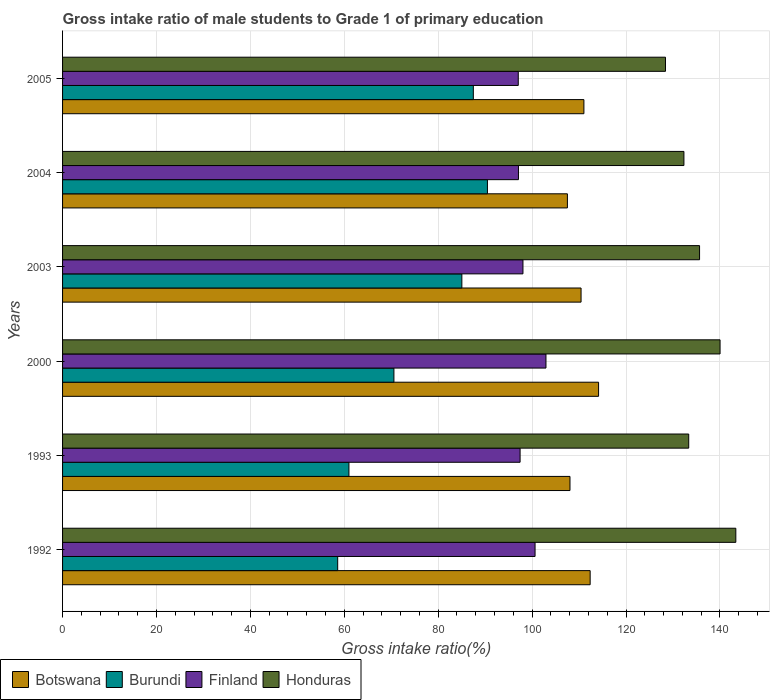Are the number of bars per tick equal to the number of legend labels?
Your answer should be compact. Yes. How many bars are there on the 4th tick from the top?
Provide a succinct answer. 4. What is the label of the 3rd group of bars from the top?
Your answer should be compact. 2003. In how many cases, is the number of bars for a given year not equal to the number of legend labels?
Make the answer very short. 0. What is the gross intake ratio in Botswana in 2005?
Provide a short and direct response. 111.03. Across all years, what is the maximum gross intake ratio in Honduras?
Your answer should be compact. 143.39. Across all years, what is the minimum gross intake ratio in Finland?
Ensure brevity in your answer.  97.05. What is the total gross intake ratio in Finland in the graph?
Your response must be concise. 593.22. What is the difference between the gross intake ratio in Finland in 1992 and that in 1993?
Offer a very short reply. 3.19. What is the difference between the gross intake ratio in Finland in 1992 and the gross intake ratio in Honduras in 2003?
Ensure brevity in your answer.  -35.03. What is the average gross intake ratio in Finland per year?
Provide a succinct answer. 98.87. In the year 2003, what is the difference between the gross intake ratio in Botswana and gross intake ratio in Finland?
Offer a very short reply. 12.38. What is the ratio of the gross intake ratio in Honduras in 2000 to that in 2005?
Keep it short and to the point. 1.09. Is the gross intake ratio in Burundi in 1992 less than that in 1993?
Provide a succinct answer. Yes. Is the difference between the gross intake ratio in Botswana in 1992 and 2003 greater than the difference between the gross intake ratio in Finland in 1992 and 2003?
Your response must be concise. No. What is the difference between the highest and the second highest gross intake ratio in Finland?
Your response must be concise. 2.32. What is the difference between the highest and the lowest gross intake ratio in Botswana?
Offer a terse response. 6.64. In how many years, is the gross intake ratio in Honduras greater than the average gross intake ratio in Honduras taken over all years?
Give a very brief answer. 3. What does the 3rd bar from the top in 2003 represents?
Your answer should be very brief. Burundi. What does the 4th bar from the bottom in 1992 represents?
Offer a terse response. Honduras. Are all the bars in the graph horizontal?
Give a very brief answer. Yes. Does the graph contain any zero values?
Your response must be concise. No. What is the title of the graph?
Keep it short and to the point. Gross intake ratio of male students to Grade 1 of primary education. Does "Seychelles" appear as one of the legend labels in the graph?
Your response must be concise. No. What is the label or title of the X-axis?
Offer a terse response. Gross intake ratio(%). What is the label or title of the Y-axis?
Offer a terse response. Years. What is the Gross intake ratio(%) in Botswana in 1992?
Your answer should be very brief. 112.36. What is the Gross intake ratio(%) in Burundi in 1992?
Make the answer very short. 58.59. What is the Gross intake ratio(%) of Finland in 1992?
Offer a terse response. 100.63. What is the Gross intake ratio(%) of Honduras in 1992?
Your response must be concise. 143.39. What is the Gross intake ratio(%) in Botswana in 1993?
Keep it short and to the point. 108.07. What is the Gross intake ratio(%) in Burundi in 1993?
Your response must be concise. 60.99. What is the Gross intake ratio(%) of Finland in 1993?
Keep it short and to the point. 97.44. What is the Gross intake ratio(%) of Honduras in 1993?
Make the answer very short. 133.35. What is the Gross intake ratio(%) of Botswana in 2000?
Your answer should be very brief. 114.16. What is the Gross intake ratio(%) of Burundi in 2000?
Ensure brevity in your answer.  70.57. What is the Gross intake ratio(%) in Finland in 2000?
Your response must be concise. 102.95. What is the Gross intake ratio(%) of Honduras in 2000?
Make the answer very short. 140.03. What is the Gross intake ratio(%) in Botswana in 2003?
Ensure brevity in your answer.  110.42. What is the Gross intake ratio(%) of Burundi in 2003?
Your response must be concise. 85.04. What is the Gross intake ratio(%) in Finland in 2003?
Keep it short and to the point. 98.05. What is the Gross intake ratio(%) in Honduras in 2003?
Offer a very short reply. 135.66. What is the Gross intake ratio(%) in Botswana in 2004?
Offer a very short reply. 107.52. What is the Gross intake ratio(%) of Burundi in 2004?
Provide a short and direct response. 90.48. What is the Gross intake ratio(%) of Finland in 2004?
Provide a short and direct response. 97.09. What is the Gross intake ratio(%) in Honduras in 2004?
Your response must be concise. 132.33. What is the Gross intake ratio(%) of Botswana in 2005?
Provide a succinct answer. 111.03. What is the Gross intake ratio(%) of Burundi in 2005?
Your answer should be compact. 87.48. What is the Gross intake ratio(%) in Finland in 2005?
Your answer should be very brief. 97.05. What is the Gross intake ratio(%) of Honduras in 2005?
Provide a succinct answer. 128.41. Across all years, what is the maximum Gross intake ratio(%) of Botswana?
Ensure brevity in your answer.  114.16. Across all years, what is the maximum Gross intake ratio(%) in Burundi?
Give a very brief answer. 90.48. Across all years, what is the maximum Gross intake ratio(%) in Finland?
Provide a short and direct response. 102.95. Across all years, what is the maximum Gross intake ratio(%) in Honduras?
Offer a very short reply. 143.39. Across all years, what is the minimum Gross intake ratio(%) in Botswana?
Offer a terse response. 107.52. Across all years, what is the minimum Gross intake ratio(%) in Burundi?
Provide a short and direct response. 58.59. Across all years, what is the minimum Gross intake ratio(%) of Finland?
Keep it short and to the point. 97.05. Across all years, what is the minimum Gross intake ratio(%) of Honduras?
Make the answer very short. 128.41. What is the total Gross intake ratio(%) in Botswana in the graph?
Your response must be concise. 663.56. What is the total Gross intake ratio(%) in Burundi in the graph?
Give a very brief answer. 453.16. What is the total Gross intake ratio(%) in Finland in the graph?
Your answer should be compact. 593.22. What is the total Gross intake ratio(%) of Honduras in the graph?
Offer a terse response. 813.17. What is the difference between the Gross intake ratio(%) of Botswana in 1992 and that in 1993?
Keep it short and to the point. 4.29. What is the difference between the Gross intake ratio(%) in Burundi in 1992 and that in 1993?
Provide a succinct answer. -2.4. What is the difference between the Gross intake ratio(%) in Finland in 1992 and that in 1993?
Give a very brief answer. 3.19. What is the difference between the Gross intake ratio(%) in Honduras in 1992 and that in 1993?
Offer a very short reply. 10.03. What is the difference between the Gross intake ratio(%) in Botswana in 1992 and that in 2000?
Make the answer very short. -1.79. What is the difference between the Gross intake ratio(%) of Burundi in 1992 and that in 2000?
Make the answer very short. -11.97. What is the difference between the Gross intake ratio(%) in Finland in 1992 and that in 2000?
Ensure brevity in your answer.  -2.32. What is the difference between the Gross intake ratio(%) of Honduras in 1992 and that in 2000?
Ensure brevity in your answer.  3.36. What is the difference between the Gross intake ratio(%) of Botswana in 1992 and that in 2003?
Make the answer very short. 1.94. What is the difference between the Gross intake ratio(%) in Burundi in 1992 and that in 2003?
Provide a succinct answer. -26.44. What is the difference between the Gross intake ratio(%) in Finland in 1992 and that in 2003?
Provide a succinct answer. 2.58. What is the difference between the Gross intake ratio(%) of Honduras in 1992 and that in 2003?
Provide a succinct answer. 7.72. What is the difference between the Gross intake ratio(%) in Botswana in 1992 and that in 2004?
Offer a very short reply. 4.84. What is the difference between the Gross intake ratio(%) in Burundi in 1992 and that in 2004?
Provide a succinct answer. -31.89. What is the difference between the Gross intake ratio(%) in Finland in 1992 and that in 2004?
Your answer should be compact. 3.54. What is the difference between the Gross intake ratio(%) of Honduras in 1992 and that in 2004?
Your answer should be very brief. 11.05. What is the difference between the Gross intake ratio(%) in Botswana in 1992 and that in 2005?
Give a very brief answer. 1.33. What is the difference between the Gross intake ratio(%) in Burundi in 1992 and that in 2005?
Provide a short and direct response. -28.89. What is the difference between the Gross intake ratio(%) of Finland in 1992 and that in 2005?
Offer a very short reply. 3.58. What is the difference between the Gross intake ratio(%) of Honduras in 1992 and that in 2005?
Offer a terse response. 14.98. What is the difference between the Gross intake ratio(%) in Botswana in 1993 and that in 2000?
Your answer should be compact. -6.09. What is the difference between the Gross intake ratio(%) of Burundi in 1993 and that in 2000?
Ensure brevity in your answer.  -9.58. What is the difference between the Gross intake ratio(%) in Finland in 1993 and that in 2000?
Provide a succinct answer. -5.51. What is the difference between the Gross intake ratio(%) in Honduras in 1993 and that in 2000?
Your answer should be very brief. -6.68. What is the difference between the Gross intake ratio(%) of Botswana in 1993 and that in 2003?
Keep it short and to the point. -2.36. What is the difference between the Gross intake ratio(%) of Burundi in 1993 and that in 2003?
Give a very brief answer. -24.05. What is the difference between the Gross intake ratio(%) in Finland in 1993 and that in 2003?
Offer a terse response. -0.61. What is the difference between the Gross intake ratio(%) in Honduras in 1993 and that in 2003?
Make the answer very short. -2.31. What is the difference between the Gross intake ratio(%) of Botswana in 1993 and that in 2004?
Offer a terse response. 0.55. What is the difference between the Gross intake ratio(%) of Burundi in 1993 and that in 2004?
Provide a succinct answer. -29.49. What is the difference between the Gross intake ratio(%) in Finland in 1993 and that in 2004?
Your answer should be compact. 0.35. What is the difference between the Gross intake ratio(%) in Honduras in 1993 and that in 2004?
Provide a short and direct response. 1.02. What is the difference between the Gross intake ratio(%) of Botswana in 1993 and that in 2005?
Provide a succinct answer. -2.97. What is the difference between the Gross intake ratio(%) in Burundi in 1993 and that in 2005?
Keep it short and to the point. -26.49. What is the difference between the Gross intake ratio(%) of Finland in 1993 and that in 2005?
Make the answer very short. 0.39. What is the difference between the Gross intake ratio(%) of Honduras in 1993 and that in 2005?
Your answer should be very brief. 4.95. What is the difference between the Gross intake ratio(%) in Botswana in 2000 and that in 2003?
Ensure brevity in your answer.  3.73. What is the difference between the Gross intake ratio(%) in Burundi in 2000 and that in 2003?
Make the answer very short. -14.47. What is the difference between the Gross intake ratio(%) of Finland in 2000 and that in 2003?
Provide a short and direct response. 4.9. What is the difference between the Gross intake ratio(%) of Honduras in 2000 and that in 2003?
Offer a terse response. 4.37. What is the difference between the Gross intake ratio(%) of Botswana in 2000 and that in 2004?
Ensure brevity in your answer.  6.64. What is the difference between the Gross intake ratio(%) of Burundi in 2000 and that in 2004?
Keep it short and to the point. -19.92. What is the difference between the Gross intake ratio(%) in Finland in 2000 and that in 2004?
Provide a succinct answer. 5.86. What is the difference between the Gross intake ratio(%) in Honduras in 2000 and that in 2004?
Give a very brief answer. 7.7. What is the difference between the Gross intake ratio(%) of Botswana in 2000 and that in 2005?
Your response must be concise. 3.12. What is the difference between the Gross intake ratio(%) in Burundi in 2000 and that in 2005?
Your answer should be very brief. -16.91. What is the difference between the Gross intake ratio(%) in Finland in 2000 and that in 2005?
Your response must be concise. 5.9. What is the difference between the Gross intake ratio(%) of Honduras in 2000 and that in 2005?
Your response must be concise. 11.62. What is the difference between the Gross intake ratio(%) in Botswana in 2003 and that in 2004?
Your answer should be compact. 2.91. What is the difference between the Gross intake ratio(%) in Burundi in 2003 and that in 2004?
Make the answer very short. -5.45. What is the difference between the Gross intake ratio(%) in Finland in 2003 and that in 2004?
Make the answer very short. 0.96. What is the difference between the Gross intake ratio(%) in Honduras in 2003 and that in 2004?
Your answer should be compact. 3.33. What is the difference between the Gross intake ratio(%) in Botswana in 2003 and that in 2005?
Offer a very short reply. -0.61. What is the difference between the Gross intake ratio(%) in Burundi in 2003 and that in 2005?
Give a very brief answer. -2.44. What is the difference between the Gross intake ratio(%) in Finland in 2003 and that in 2005?
Ensure brevity in your answer.  1. What is the difference between the Gross intake ratio(%) of Honduras in 2003 and that in 2005?
Offer a very short reply. 7.26. What is the difference between the Gross intake ratio(%) in Botswana in 2004 and that in 2005?
Ensure brevity in your answer.  -3.52. What is the difference between the Gross intake ratio(%) in Burundi in 2004 and that in 2005?
Your response must be concise. 3. What is the difference between the Gross intake ratio(%) in Finland in 2004 and that in 2005?
Make the answer very short. 0.04. What is the difference between the Gross intake ratio(%) of Honduras in 2004 and that in 2005?
Offer a very short reply. 3.93. What is the difference between the Gross intake ratio(%) in Botswana in 1992 and the Gross intake ratio(%) in Burundi in 1993?
Offer a terse response. 51.37. What is the difference between the Gross intake ratio(%) in Botswana in 1992 and the Gross intake ratio(%) in Finland in 1993?
Offer a terse response. 14.92. What is the difference between the Gross intake ratio(%) of Botswana in 1992 and the Gross intake ratio(%) of Honduras in 1993?
Provide a succinct answer. -20.99. What is the difference between the Gross intake ratio(%) in Burundi in 1992 and the Gross intake ratio(%) in Finland in 1993?
Keep it short and to the point. -38.85. What is the difference between the Gross intake ratio(%) in Burundi in 1992 and the Gross intake ratio(%) in Honduras in 1993?
Give a very brief answer. -74.76. What is the difference between the Gross intake ratio(%) in Finland in 1992 and the Gross intake ratio(%) in Honduras in 1993?
Offer a very short reply. -32.73. What is the difference between the Gross intake ratio(%) of Botswana in 1992 and the Gross intake ratio(%) of Burundi in 2000?
Provide a succinct answer. 41.79. What is the difference between the Gross intake ratio(%) of Botswana in 1992 and the Gross intake ratio(%) of Finland in 2000?
Make the answer very short. 9.41. What is the difference between the Gross intake ratio(%) in Botswana in 1992 and the Gross intake ratio(%) in Honduras in 2000?
Make the answer very short. -27.67. What is the difference between the Gross intake ratio(%) in Burundi in 1992 and the Gross intake ratio(%) in Finland in 2000?
Ensure brevity in your answer.  -44.36. What is the difference between the Gross intake ratio(%) in Burundi in 1992 and the Gross intake ratio(%) in Honduras in 2000?
Ensure brevity in your answer.  -81.44. What is the difference between the Gross intake ratio(%) in Finland in 1992 and the Gross intake ratio(%) in Honduras in 2000?
Provide a short and direct response. -39.4. What is the difference between the Gross intake ratio(%) of Botswana in 1992 and the Gross intake ratio(%) of Burundi in 2003?
Keep it short and to the point. 27.32. What is the difference between the Gross intake ratio(%) in Botswana in 1992 and the Gross intake ratio(%) in Finland in 2003?
Make the answer very short. 14.31. What is the difference between the Gross intake ratio(%) of Botswana in 1992 and the Gross intake ratio(%) of Honduras in 2003?
Offer a terse response. -23.3. What is the difference between the Gross intake ratio(%) in Burundi in 1992 and the Gross intake ratio(%) in Finland in 2003?
Offer a terse response. -39.45. What is the difference between the Gross intake ratio(%) in Burundi in 1992 and the Gross intake ratio(%) in Honduras in 2003?
Make the answer very short. -77.07. What is the difference between the Gross intake ratio(%) of Finland in 1992 and the Gross intake ratio(%) of Honduras in 2003?
Keep it short and to the point. -35.03. What is the difference between the Gross intake ratio(%) in Botswana in 1992 and the Gross intake ratio(%) in Burundi in 2004?
Your answer should be compact. 21.88. What is the difference between the Gross intake ratio(%) in Botswana in 1992 and the Gross intake ratio(%) in Finland in 2004?
Your answer should be compact. 15.27. What is the difference between the Gross intake ratio(%) of Botswana in 1992 and the Gross intake ratio(%) of Honduras in 2004?
Your response must be concise. -19.97. What is the difference between the Gross intake ratio(%) in Burundi in 1992 and the Gross intake ratio(%) in Finland in 2004?
Give a very brief answer. -38.5. What is the difference between the Gross intake ratio(%) of Burundi in 1992 and the Gross intake ratio(%) of Honduras in 2004?
Offer a very short reply. -73.74. What is the difference between the Gross intake ratio(%) of Finland in 1992 and the Gross intake ratio(%) of Honduras in 2004?
Keep it short and to the point. -31.7. What is the difference between the Gross intake ratio(%) of Botswana in 1992 and the Gross intake ratio(%) of Burundi in 2005?
Your answer should be very brief. 24.88. What is the difference between the Gross intake ratio(%) in Botswana in 1992 and the Gross intake ratio(%) in Finland in 2005?
Provide a succinct answer. 15.31. What is the difference between the Gross intake ratio(%) in Botswana in 1992 and the Gross intake ratio(%) in Honduras in 2005?
Provide a succinct answer. -16.04. What is the difference between the Gross intake ratio(%) in Burundi in 1992 and the Gross intake ratio(%) in Finland in 2005?
Provide a short and direct response. -38.46. What is the difference between the Gross intake ratio(%) of Burundi in 1992 and the Gross intake ratio(%) of Honduras in 2005?
Provide a short and direct response. -69.81. What is the difference between the Gross intake ratio(%) in Finland in 1992 and the Gross intake ratio(%) in Honduras in 2005?
Ensure brevity in your answer.  -27.78. What is the difference between the Gross intake ratio(%) of Botswana in 1993 and the Gross intake ratio(%) of Burundi in 2000?
Your response must be concise. 37.5. What is the difference between the Gross intake ratio(%) of Botswana in 1993 and the Gross intake ratio(%) of Finland in 2000?
Make the answer very short. 5.11. What is the difference between the Gross intake ratio(%) in Botswana in 1993 and the Gross intake ratio(%) in Honduras in 2000?
Your answer should be very brief. -31.96. What is the difference between the Gross intake ratio(%) of Burundi in 1993 and the Gross intake ratio(%) of Finland in 2000?
Offer a terse response. -41.96. What is the difference between the Gross intake ratio(%) of Burundi in 1993 and the Gross intake ratio(%) of Honduras in 2000?
Offer a very short reply. -79.04. What is the difference between the Gross intake ratio(%) of Finland in 1993 and the Gross intake ratio(%) of Honduras in 2000?
Keep it short and to the point. -42.59. What is the difference between the Gross intake ratio(%) of Botswana in 1993 and the Gross intake ratio(%) of Burundi in 2003?
Your response must be concise. 23.03. What is the difference between the Gross intake ratio(%) of Botswana in 1993 and the Gross intake ratio(%) of Finland in 2003?
Offer a terse response. 10.02. What is the difference between the Gross intake ratio(%) in Botswana in 1993 and the Gross intake ratio(%) in Honduras in 2003?
Your answer should be very brief. -27.6. What is the difference between the Gross intake ratio(%) of Burundi in 1993 and the Gross intake ratio(%) of Finland in 2003?
Give a very brief answer. -37.06. What is the difference between the Gross intake ratio(%) of Burundi in 1993 and the Gross intake ratio(%) of Honduras in 2003?
Give a very brief answer. -74.67. What is the difference between the Gross intake ratio(%) in Finland in 1993 and the Gross intake ratio(%) in Honduras in 2003?
Offer a terse response. -38.22. What is the difference between the Gross intake ratio(%) of Botswana in 1993 and the Gross intake ratio(%) of Burundi in 2004?
Provide a succinct answer. 17.58. What is the difference between the Gross intake ratio(%) of Botswana in 1993 and the Gross intake ratio(%) of Finland in 2004?
Ensure brevity in your answer.  10.97. What is the difference between the Gross intake ratio(%) of Botswana in 1993 and the Gross intake ratio(%) of Honduras in 2004?
Offer a very short reply. -24.27. What is the difference between the Gross intake ratio(%) in Burundi in 1993 and the Gross intake ratio(%) in Finland in 2004?
Provide a succinct answer. -36.1. What is the difference between the Gross intake ratio(%) of Burundi in 1993 and the Gross intake ratio(%) of Honduras in 2004?
Your answer should be very brief. -71.34. What is the difference between the Gross intake ratio(%) of Finland in 1993 and the Gross intake ratio(%) of Honduras in 2004?
Provide a short and direct response. -34.89. What is the difference between the Gross intake ratio(%) in Botswana in 1993 and the Gross intake ratio(%) in Burundi in 2005?
Keep it short and to the point. 20.59. What is the difference between the Gross intake ratio(%) of Botswana in 1993 and the Gross intake ratio(%) of Finland in 2005?
Give a very brief answer. 11.01. What is the difference between the Gross intake ratio(%) in Botswana in 1993 and the Gross intake ratio(%) in Honduras in 2005?
Offer a very short reply. -20.34. What is the difference between the Gross intake ratio(%) of Burundi in 1993 and the Gross intake ratio(%) of Finland in 2005?
Give a very brief answer. -36.06. What is the difference between the Gross intake ratio(%) in Burundi in 1993 and the Gross intake ratio(%) in Honduras in 2005?
Your answer should be compact. -67.42. What is the difference between the Gross intake ratio(%) in Finland in 1993 and the Gross intake ratio(%) in Honduras in 2005?
Provide a short and direct response. -30.97. What is the difference between the Gross intake ratio(%) in Botswana in 2000 and the Gross intake ratio(%) in Burundi in 2003?
Your answer should be very brief. 29.12. What is the difference between the Gross intake ratio(%) of Botswana in 2000 and the Gross intake ratio(%) of Finland in 2003?
Make the answer very short. 16.11. What is the difference between the Gross intake ratio(%) of Botswana in 2000 and the Gross intake ratio(%) of Honduras in 2003?
Provide a succinct answer. -21.51. What is the difference between the Gross intake ratio(%) of Burundi in 2000 and the Gross intake ratio(%) of Finland in 2003?
Give a very brief answer. -27.48. What is the difference between the Gross intake ratio(%) in Burundi in 2000 and the Gross intake ratio(%) in Honduras in 2003?
Your answer should be compact. -65.09. What is the difference between the Gross intake ratio(%) in Finland in 2000 and the Gross intake ratio(%) in Honduras in 2003?
Provide a succinct answer. -32.71. What is the difference between the Gross intake ratio(%) in Botswana in 2000 and the Gross intake ratio(%) in Burundi in 2004?
Make the answer very short. 23.67. What is the difference between the Gross intake ratio(%) in Botswana in 2000 and the Gross intake ratio(%) in Finland in 2004?
Keep it short and to the point. 17.06. What is the difference between the Gross intake ratio(%) of Botswana in 2000 and the Gross intake ratio(%) of Honduras in 2004?
Make the answer very short. -18.18. What is the difference between the Gross intake ratio(%) in Burundi in 2000 and the Gross intake ratio(%) in Finland in 2004?
Make the answer very short. -26.52. What is the difference between the Gross intake ratio(%) in Burundi in 2000 and the Gross intake ratio(%) in Honduras in 2004?
Ensure brevity in your answer.  -61.77. What is the difference between the Gross intake ratio(%) of Finland in 2000 and the Gross intake ratio(%) of Honduras in 2004?
Give a very brief answer. -29.38. What is the difference between the Gross intake ratio(%) in Botswana in 2000 and the Gross intake ratio(%) in Burundi in 2005?
Provide a short and direct response. 26.67. What is the difference between the Gross intake ratio(%) of Botswana in 2000 and the Gross intake ratio(%) of Finland in 2005?
Keep it short and to the point. 17.1. What is the difference between the Gross intake ratio(%) of Botswana in 2000 and the Gross intake ratio(%) of Honduras in 2005?
Ensure brevity in your answer.  -14.25. What is the difference between the Gross intake ratio(%) in Burundi in 2000 and the Gross intake ratio(%) in Finland in 2005?
Ensure brevity in your answer.  -26.48. What is the difference between the Gross intake ratio(%) of Burundi in 2000 and the Gross intake ratio(%) of Honduras in 2005?
Keep it short and to the point. -57.84. What is the difference between the Gross intake ratio(%) in Finland in 2000 and the Gross intake ratio(%) in Honduras in 2005?
Make the answer very short. -25.45. What is the difference between the Gross intake ratio(%) in Botswana in 2003 and the Gross intake ratio(%) in Burundi in 2004?
Your answer should be compact. 19.94. What is the difference between the Gross intake ratio(%) in Botswana in 2003 and the Gross intake ratio(%) in Finland in 2004?
Your response must be concise. 13.33. What is the difference between the Gross intake ratio(%) of Botswana in 2003 and the Gross intake ratio(%) of Honduras in 2004?
Give a very brief answer. -21.91. What is the difference between the Gross intake ratio(%) of Burundi in 2003 and the Gross intake ratio(%) of Finland in 2004?
Give a very brief answer. -12.06. What is the difference between the Gross intake ratio(%) of Burundi in 2003 and the Gross intake ratio(%) of Honduras in 2004?
Give a very brief answer. -47.3. What is the difference between the Gross intake ratio(%) in Finland in 2003 and the Gross intake ratio(%) in Honduras in 2004?
Offer a very short reply. -34.28. What is the difference between the Gross intake ratio(%) of Botswana in 2003 and the Gross intake ratio(%) of Burundi in 2005?
Keep it short and to the point. 22.94. What is the difference between the Gross intake ratio(%) in Botswana in 2003 and the Gross intake ratio(%) in Finland in 2005?
Your answer should be very brief. 13.37. What is the difference between the Gross intake ratio(%) of Botswana in 2003 and the Gross intake ratio(%) of Honduras in 2005?
Keep it short and to the point. -17.98. What is the difference between the Gross intake ratio(%) of Burundi in 2003 and the Gross intake ratio(%) of Finland in 2005?
Ensure brevity in your answer.  -12.02. What is the difference between the Gross intake ratio(%) of Burundi in 2003 and the Gross intake ratio(%) of Honduras in 2005?
Give a very brief answer. -43.37. What is the difference between the Gross intake ratio(%) of Finland in 2003 and the Gross intake ratio(%) of Honduras in 2005?
Offer a very short reply. -30.36. What is the difference between the Gross intake ratio(%) in Botswana in 2004 and the Gross intake ratio(%) in Burundi in 2005?
Your response must be concise. 20.03. What is the difference between the Gross intake ratio(%) of Botswana in 2004 and the Gross intake ratio(%) of Finland in 2005?
Your answer should be compact. 10.46. What is the difference between the Gross intake ratio(%) of Botswana in 2004 and the Gross intake ratio(%) of Honduras in 2005?
Offer a terse response. -20.89. What is the difference between the Gross intake ratio(%) in Burundi in 2004 and the Gross intake ratio(%) in Finland in 2005?
Your answer should be compact. -6.57. What is the difference between the Gross intake ratio(%) in Burundi in 2004 and the Gross intake ratio(%) in Honduras in 2005?
Your answer should be very brief. -37.92. What is the difference between the Gross intake ratio(%) in Finland in 2004 and the Gross intake ratio(%) in Honduras in 2005?
Keep it short and to the point. -31.31. What is the average Gross intake ratio(%) of Botswana per year?
Your response must be concise. 110.59. What is the average Gross intake ratio(%) in Burundi per year?
Provide a succinct answer. 75.53. What is the average Gross intake ratio(%) of Finland per year?
Give a very brief answer. 98.87. What is the average Gross intake ratio(%) of Honduras per year?
Your response must be concise. 135.53. In the year 1992, what is the difference between the Gross intake ratio(%) in Botswana and Gross intake ratio(%) in Burundi?
Provide a succinct answer. 53.77. In the year 1992, what is the difference between the Gross intake ratio(%) of Botswana and Gross intake ratio(%) of Finland?
Keep it short and to the point. 11.73. In the year 1992, what is the difference between the Gross intake ratio(%) in Botswana and Gross intake ratio(%) in Honduras?
Make the answer very short. -31.03. In the year 1992, what is the difference between the Gross intake ratio(%) of Burundi and Gross intake ratio(%) of Finland?
Your response must be concise. -42.03. In the year 1992, what is the difference between the Gross intake ratio(%) in Burundi and Gross intake ratio(%) in Honduras?
Ensure brevity in your answer.  -84.79. In the year 1992, what is the difference between the Gross intake ratio(%) of Finland and Gross intake ratio(%) of Honduras?
Offer a terse response. -42.76. In the year 1993, what is the difference between the Gross intake ratio(%) of Botswana and Gross intake ratio(%) of Burundi?
Your response must be concise. 47.08. In the year 1993, what is the difference between the Gross intake ratio(%) of Botswana and Gross intake ratio(%) of Finland?
Give a very brief answer. 10.63. In the year 1993, what is the difference between the Gross intake ratio(%) of Botswana and Gross intake ratio(%) of Honduras?
Your response must be concise. -25.29. In the year 1993, what is the difference between the Gross intake ratio(%) of Burundi and Gross intake ratio(%) of Finland?
Your answer should be very brief. -36.45. In the year 1993, what is the difference between the Gross intake ratio(%) of Burundi and Gross intake ratio(%) of Honduras?
Your answer should be compact. -72.36. In the year 1993, what is the difference between the Gross intake ratio(%) of Finland and Gross intake ratio(%) of Honduras?
Give a very brief answer. -35.91. In the year 2000, what is the difference between the Gross intake ratio(%) in Botswana and Gross intake ratio(%) in Burundi?
Provide a succinct answer. 43.59. In the year 2000, what is the difference between the Gross intake ratio(%) of Botswana and Gross intake ratio(%) of Finland?
Give a very brief answer. 11.2. In the year 2000, what is the difference between the Gross intake ratio(%) in Botswana and Gross intake ratio(%) in Honduras?
Your answer should be very brief. -25.87. In the year 2000, what is the difference between the Gross intake ratio(%) in Burundi and Gross intake ratio(%) in Finland?
Provide a short and direct response. -32.38. In the year 2000, what is the difference between the Gross intake ratio(%) of Burundi and Gross intake ratio(%) of Honduras?
Provide a short and direct response. -69.46. In the year 2000, what is the difference between the Gross intake ratio(%) of Finland and Gross intake ratio(%) of Honduras?
Your response must be concise. -37.08. In the year 2003, what is the difference between the Gross intake ratio(%) of Botswana and Gross intake ratio(%) of Burundi?
Keep it short and to the point. 25.39. In the year 2003, what is the difference between the Gross intake ratio(%) in Botswana and Gross intake ratio(%) in Finland?
Provide a short and direct response. 12.38. In the year 2003, what is the difference between the Gross intake ratio(%) in Botswana and Gross intake ratio(%) in Honduras?
Keep it short and to the point. -25.24. In the year 2003, what is the difference between the Gross intake ratio(%) in Burundi and Gross intake ratio(%) in Finland?
Your answer should be very brief. -13.01. In the year 2003, what is the difference between the Gross intake ratio(%) in Burundi and Gross intake ratio(%) in Honduras?
Your answer should be very brief. -50.63. In the year 2003, what is the difference between the Gross intake ratio(%) in Finland and Gross intake ratio(%) in Honduras?
Offer a very short reply. -37.61. In the year 2004, what is the difference between the Gross intake ratio(%) of Botswana and Gross intake ratio(%) of Burundi?
Your answer should be very brief. 17.03. In the year 2004, what is the difference between the Gross intake ratio(%) in Botswana and Gross intake ratio(%) in Finland?
Make the answer very short. 10.42. In the year 2004, what is the difference between the Gross intake ratio(%) in Botswana and Gross intake ratio(%) in Honduras?
Your answer should be very brief. -24.82. In the year 2004, what is the difference between the Gross intake ratio(%) of Burundi and Gross intake ratio(%) of Finland?
Your answer should be very brief. -6.61. In the year 2004, what is the difference between the Gross intake ratio(%) of Burundi and Gross intake ratio(%) of Honduras?
Offer a terse response. -41.85. In the year 2004, what is the difference between the Gross intake ratio(%) in Finland and Gross intake ratio(%) in Honduras?
Your answer should be very brief. -35.24. In the year 2005, what is the difference between the Gross intake ratio(%) of Botswana and Gross intake ratio(%) of Burundi?
Your answer should be compact. 23.55. In the year 2005, what is the difference between the Gross intake ratio(%) of Botswana and Gross intake ratio(%) of Finland?
Ensure brevity in your answer.  13.98. In the year 2005, what is the difference between the Gross intake ratio(%) in Botswana and Gross intake ratio(%) in Honduras?
Your answer should be very brief. -17.37. In the year 2005, what is the difference between the Gross intake ratio(%) of Burundi and Gross intake ratio(%) of Finland?
Your answer should be compact. -9.57. In the year 2005, what is the difference between the Gross intake ratio(%) in Burundi and Gross intake ratio(%) in Honduras?
Your answer should be compact. -40.92. In the year 2005, what is the difference between the Gross intake ratio(%) in Finland and Gross intake ratio(%) in Honduras?
Ensure brevity in your answer.  -31.35. What is the ratio of the Gross intake ratio(%) in Botswana in 1992 to that in 1993?
Your response must be concise. 1.04. What is the ratio of the Gross intake ratio(%) in Burundi in 1992 to that in 1993?
Offer a very short reply. 0.96. What is the ratio of the Gross intake ratio(%) in Finland in 1992 to that in 1993?
Provide a succinct answer. 1.03. What is the ratio of the Gross intake ratio(%) in Honduras in 1992 to that in 1993?
Offer a terse response. 1.08. What is the ratio of the Gross intake ratio(%) of Botswana in 1992 to that in 2000?
Give a very brief answer. 0.98. What is the ratio of the Gross intake ratio(%) of Burundi in 1992 to that in 2000?
Keep it short and to the point. 0.83. What is the ratio of the Gross intake ratio(%) in Finland in 1992 to that in 2000?
Make the answer very short. 0.98. What is the ratio of the Gross intake ratio(%) in Botswana in 1992 to that in 2003?
Your response must be concise. 1.02. What is the ratio of the Gross intake ratio(%) of Burundi in 1992 to that in 2003?
Keep it short and to the point. 0.69. What is the ratio of the Gross intake ratio(%) of Finland in 1992 to that in 2003?
Your answer should be compact. 1.03. What is the ratio of the Gross intake ratio(%) of Honduras in 1992 to that in 2003?
Your answer should be very brief. 1.06. What is the ratio of the Gross intake ratio(%) in Botswana in 1992 to that in 2004?
Provide a succinct answer. 1.05. What is the ratio of the Gross intake ratio(%) in Burundi in 1992 to that in 2004?
Offer a terse response. 0.65. What is the ratio of the Gross intake ratio(%) in Finland in 1992 to that in 2004?
Provide a succinct answer. 1.04. What is the ratio of the Gross intake ratio(%) of Honduras in 1992 to that in 2004?
Provide a succinct answer. 1.08. What is the ratio of the Gross intake ratio(%) of Burundi in 1992 to that in 2005?
Your answer should be compact. 0.67. What is the ratio of the Gross intake ratio(%) in Finland in 1992 to that in 2005?
Keep it short and to the point. 1.04. What is the ratio of the Gross intake ratio(%) in Honduras in 1992 to that in 2005?
Make the answer very short. 1.12. What is the ratio of the Gross intake ratio(%) of Botswana in 1993 to that in 2000?
Your answer should be compact. 0.95. What is the ratio of the Gross intake ratio(%) of Burundi in 1993 to that in 2000?
Give a very brief answer. 0.86. What is the ratio of the Gross intake ratio(%) in Finland in 1993 to that in 2000?
Give a very brief answer. 0.95. What is the ratio of the Gross intake ratio(%) in Honduras in 1993 to that in 2000?
Your answer should be compact. 0.95. What is the ratio of the Gross intake ratio(%) of Botswana in 1993 to that in 2003?
Offer a terse response. 0.98. What is the ratio of the Gross intake ratio(%) in Burundi in 1993 to that in 2003?
Give a very brief answer. 0.72. What is the ratio of the Gross intake ratio(%) in Finland in 1993 to that in 2003?
Offer a terse response. 0.99. What is the ratio of the Gross intake ratio(%) in Botswana in 1993 to that in 2004?
Ensure brevity in your answer.  1.01. What is the ratio of the Gross intake ratio(%) of Burundi in 1993 to that in 2004?
Offer a terse response. 0.67. What is the ratio of the Gross intake ratio(%) of Finland in 1993 to that in 2004?
Provide a succinct answer. 1. What is the ratio of the Gross intake ratio(%) of Honduras in 1993 to that in 2004?
Ensure brevity in your answer.  1.01. What is the ratio of the Gross intake ratio(%) of Botswana in 1993 to that in 2005?
Offer a very short reply. 0.97. What is the ratio of the Gross intake ratio(%) of Burundi in 1993 to that in 2005?
Offer a very short reply. 0.7. What is the ratio of the Gross intake ratio(%) of Honduras in 1993 to that in 2005?
Provide a short and direct response. 1.04. What is the ratio of the Gross intake ratio(%) of Botswana in 2000 to that in 2003?
Your answer should be compact. 1.03. What is the ratio of the Gross intake ratio(%) of Burundi in 2000 to that in 2003?
Your answer should be very brief. 0.83. What is the ratio of the Gross intake ratio(%) in Finland in 2000 to that in 2003?
Provide a succinct answer. 1.05. What is the ratio of the Gross intake ratio(%) of Honduras in 2000 to that in 2003?
Offer a very short reply. 1.03. What is the ratio of the Gross intake ratio(%) in Botswana in 2000 to that in 2004?
Your answer should be compact. 1.06. What is the ratio of the Gross intake ratio(%) of Burundi in 2000 to that in 2004?
Offer a very short reply. 0.78. What is the ratio of the Gross intake ratio(%) in Finland in 2000 to that in 2004?
Offer a very short reply. 1.06. What is the ratio of the Gross intake ratio(%) in Honduras in 2000 to that in 2004?
Make the answer very short. 1.06. What is the ratio of the Gross intake ratio(%) of Botswana in 2000 to that in 2005?
Provide a short and direct response. 1.03. What is the ratio of the Gross intake ratio(%) of Burundi in 2000 to that in 2005?
Your answer should be compact. 0.81. What is the ratio of the Gross intake ratio(%) in Finland in 2000 to that in 2005?
Offer a terse response. 1.06. What is the ratio of the Gross intake ratio(%) of Honduras in 2000 to that in 2005?
Your answer should be compact. 1.09. What is the ratio of the Gross intake ratio(%) in Botswana in 2003 to that in 2004?
Your response must be concise. 1.03. What is the ratio of the Gross intake ratio(%) in Burundi in 2003 to that in 2004?
Provide a succinct answer. 0.94. What is the ratio of the Gross intake ratio(%) of Finland in 2003 to that in 2004?
Your response must be concise. 1.01. What is the ratio of the Gross intake ratio(%) in Honduras in 2003 to that in 2004?
Provide a succinct answer. 1.03. What is the ratio of the Gross intake ratio(%) in Burundi in 2003 to that in 2005?
Give a very brief answer. 0.97. What is the ratio of the Gross intake ratio(%) in Finland in 2003 to that in 2005?
Your response must be concise. 1.01. What is the ratio of the Gross intake ratio(%) of Honduras in 2003 to that in 2005?
Keep it short and to the point. 1.06. What is the ratio of the Gross intake ratio(%) in Botswana in 2004 to that in 2005?
Offer a very short reply. 0.97. What is the ratio of the Gross intake ratio(%) in Burundi in 2004 to that in 2005?
Provide a succinct answer. 1.03. What is the ratio of the Gross intake ratio(%) of Honduras in 2004 to that in 2005?
Make the answer very short. 1.03. What is the difference between the highest and the second highest Gross intake ratio(%) in Botswana?
Your answer should be very brief. 1.79. What is the difference between the highest and the second highest Gross intake ratio(%) of Burundi?
Keep it short and to the point. 3. What is the difference between the highest and the second highest Gross intake ratio(%) in Finland?
Provide a short and direct response. 2.32. What is the difference between the highest and the second highest Gross intake ratio(%) in Honduras?
Keep it short and to the point. 3.36. What is the difference between the highest and the lowest Gross intake ratio(%) in Botswana?
Provide a short and direct response. 6.64. What is the difference between the highest and the lowest Gross intake ratio(%) in Burundi?
Offer a terse response. 31.89. What is the difference between the highest and the lowest Gross intake ratio(%) in Finland?
Make the answer very short. 5.9. What is the difference between the highest and the lowest Gross intake ratio(%) in Honduras?
Ensure brevity in your answer.  14.98. 